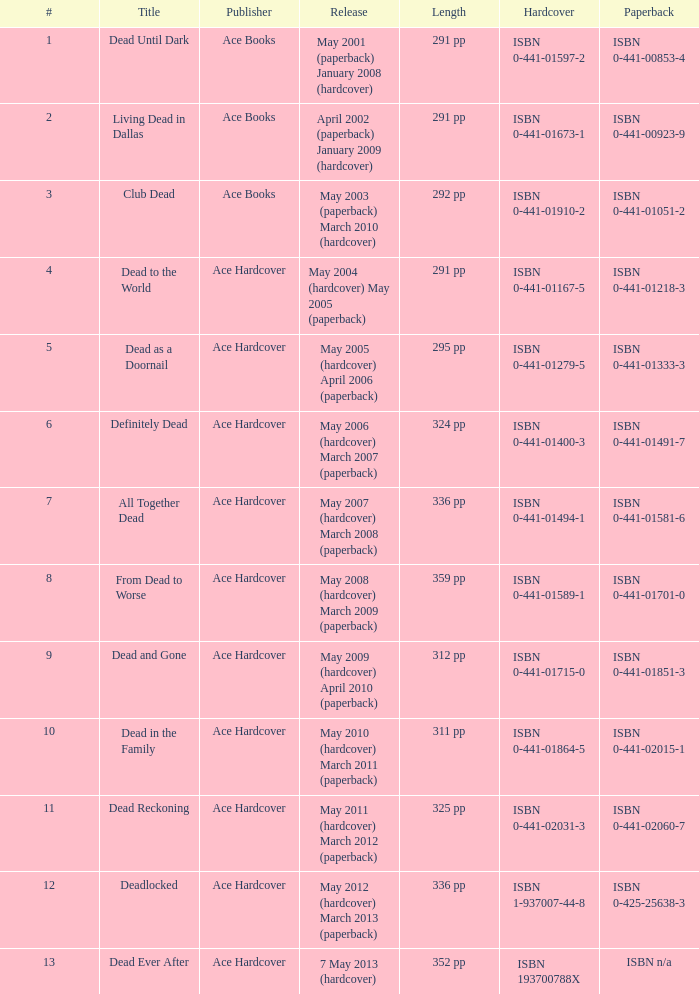How many publishers put out isbn 193700788x? 1.0. Could you parse the entire table? {'header': ['#', 'Title', 'Publisher', 'Release', 'Length', 'Hardcover', 'Paperback'], 'rows': [['1', 'Dead Until Dark', 'Ace Books', 'May 2001 (paperback) January 2008 (hardcover)', '291 pp', 'ISBN 0-441-01597-2', 'ISBN 0-441-00853-4'], ['2', 'Living Dead in Dallas', 'Ace Books', 'April 2002 (paperback) January 2009 (hardcover)', '291 pp', 'ISBN 0-441-01673-1', 'ISBN 0-441-00923-9'], ['3', 'Club Dead', 'Ace Books', 'May 2003 (paperback) March 2010 (hardcover)', '292 pp', 'ISBN 0-441-01910-2', 'ISBN 0-441-01051-2'], ['4', 'Dead to the World', 'Ace Hardcover', 'May 2004 (hardcover) May 2005 (paperback)', '291 pp', 'ISBN 0-441-01167-5', 'ISBN 0-441-01218-3'], ['5', 'Dead as a Doornail', 'Ace Hardcover', 'May 2005 (hardcover) April 2006 (paperback)', '295 pp', 'ISBN 0-441-01279-5', 'ISBN 0-441-01333-3'], ['6', 'Definitely Dead', 'Ace Hardcover', 'May 2006 (hardcover) March 2007 (paperback)', '324 pp', 'ISBN 0-441-01400-3', 'ISBN 0-441-01491-7'], ['7', 'All Together Dead', 'Ace Hardcover', 'May 2007 (hardcover) March 2008 (paperback)', '336 pp', 'ISBN 0-441-01494-1', 'ISBN 0-441-01581-6'], ['8', 'From Dead to Worse', 'Ace Hardcover', 'May 2008 (hardcover) March 2009 (paperback)', '359 pp', 'ISBN 0-441-01589-1', 'ISBN 0-441-01701-0'], ['9', 'Dead and Gone', 'Ace Hardcover', 'May 2009 (hardcover) April 2010 (paperback)', '312 pp', 'ISBN 0-441-01715-0', 'ISBN 0-441-01851-3'], ['10', 'Dead in the Family', 'Ace Hardcover', 'May 2010 (hardcover) March 2011 (paperback)', '311 pp', 'ISBN 0-441-01864-5', 'ISBN 0-441-02015-1'], ['11', 'Dead Reckoning', 'Ace Hardcover', 'May 2011 (hardcover) March 2012 (paperback)', '325 pp', 'ISBN 0-441-02031-3', 'ISBN 0-441-02060-7'], ['12', 'Deadlocked', 'Ace Hardcover', 'May 2012 (hardcover) March 2013 (paperback)', '336 pp', 'ISBN 1-937007-44-8', 'ISBN 0-425-25638-3'], ['13', 'Dead Ever After', 'Ace Hardcover', '7 May 2013 (hardcover)', '352 pp', 'ISBN 193700788X', 'ISBN n/a']]} 